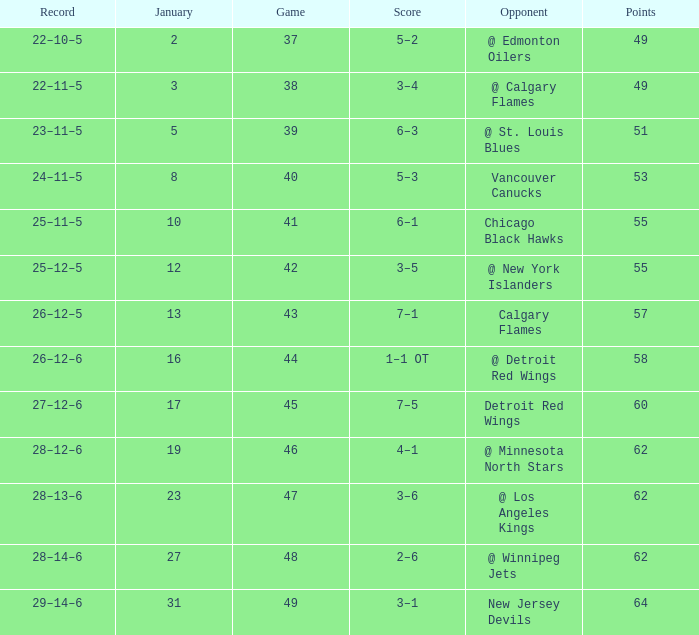How many Games have a Score of 2–6, and Points larger than 62? 0.0. Would you be able to parse every entry in this table? {'header': ['Record', 'January', 'Game', 'Score', 'Opponent', 'Points'], 'rows': [['22–10–5', '2', '37', '5–2', '@ Edmonton Oilers', '49'], ['22–11–5', '3', '38', '3–4', '@ Calgary Flames', '49'], ['23–11–5', '5', '39', '6–3', '@ St. Louis Blues', '51'], ['24–11–5', '8', '40', '5–3', 'Vancouver Canucks', '53'], ['25–11–5', '10', '41', '6–1', 'Chicago Black Hawks', '55'], ['25–12–5', '12', '42', '3–5', '@ New York Islanders', '55'], ['26–12–5', '13', '43', '7–1', 'Calgary Flames', '57'], ['26–12–6', '16', '44', '1–1 OT', '@ Detroit Red Wings', '58'], ['27–12–6', '17', '45', '7–5', 'Detroit Red Wings', '60'], ['28–12–6', '19', '46', '4–1', '@ Minnesota North Stars', '62'], ['28–13–6', '23', '47', '3–6', '@ Los Angeles Kings', '62'], ['28–14–6', '27', '48', '2–6', '@ Winnipeg Jets', '62'], ['29–14–6', '31', '49', '3–1', 'New Jersey Devils', '64']]} 